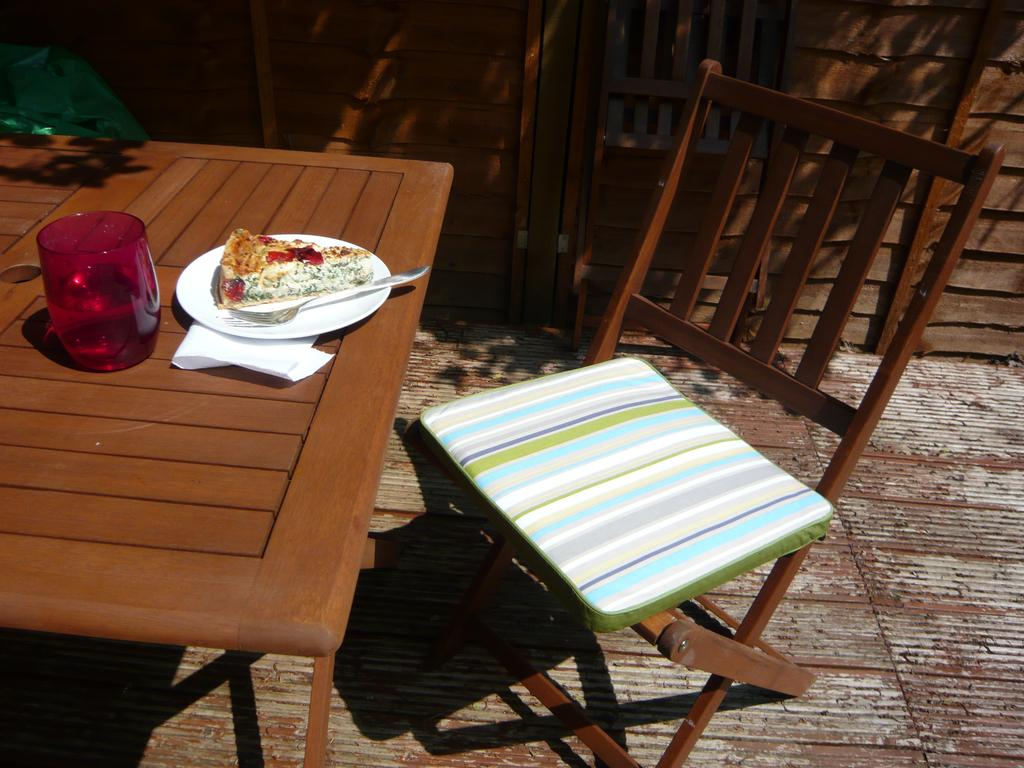What type of furniture is present in the image? There is a chair in the image. What else can be seen on the table besides the chair? There is food and a glass in the image. Where are all of these objects located? All of these objects are on a table. What type of cable is visible in the image? There is no cable present in the image. What type of meal is being prepared in the image? The image does not show any meal preparation; it only shows food on a table. 